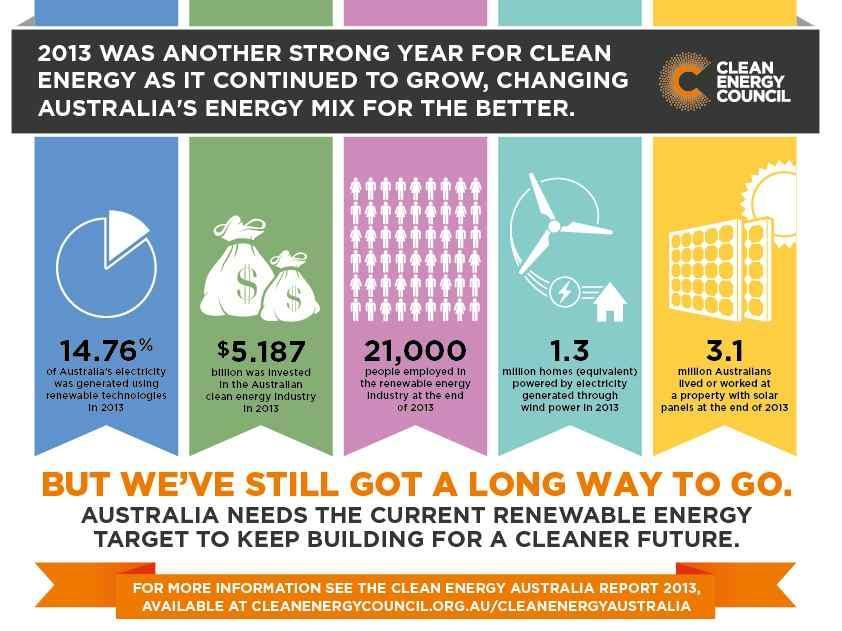How many houses were lit up using power from wind energy, 1.3 million or 3.1 million?
Answer the question with a short phrase. 1.3 million 